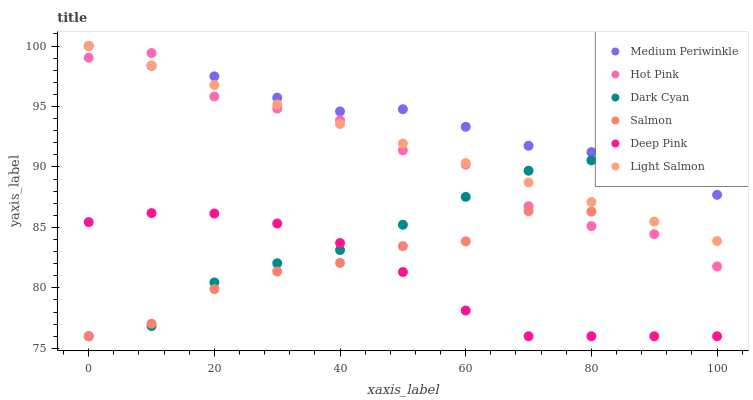Does Deep Pink have the minimum area under the curve?
Answer yes or no. Yes. Does Medium Periwinkle have the maximum area under the curve?
Answer yes or no. Yes. Does Medium Periwinkle have the minimum area under the curve?
Answer yes or no. No. Does Deep Pink have the maximum area under the curve?
Answer yes or no. No. Is Light Salmon the smoothest?
Answer yes or no. Yes. Is Hot Pink the roughest?
Answer yes or no. Yes. Is Deep Pink the smoothest?
Answer yes or no. No. Is Deep Pink the roughest?
Answer yes or no. No. Does Deep Pink have the lowest value?
Answer yes or no. Yes. Does Medium Periwinkle have the lowest value?
Answer yes or no. No. Does Medium Periwinkle have the highest value?
Answer yes or no. Yes. Does Deep Pink have the highest value?
Answer yes or no. No. Is Deep Pink less than Medium Periwinkle?
Answer yes or no. Yes. Is Light Salmon greater than Deep Pink?
Answer yes or no. Yes. Does Medium Periwinkle intersect Salmon?
Answer yes or no. Yes. Is Medium Periwinkle less than Salmon?
Answer yes or no. No. Is Medium Periwinkle greater than Salmon?
Answer yes or no. No. Does Deep Pink intersect Medium Periwinkle?
Answer yes or no. No. 